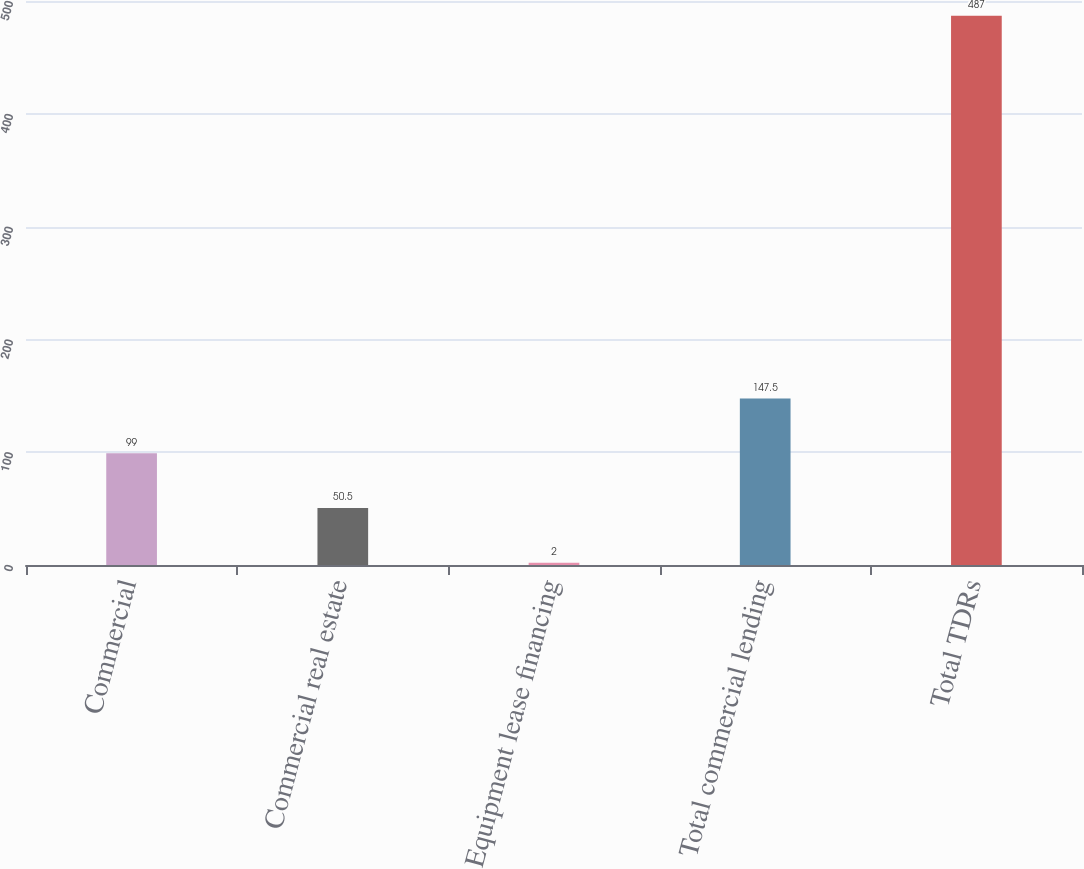<chart> <loc_0><loc_0><loc_500><loc_500><bar_chart><fcel>Commercial<fcel>Commercial real estate<fcel>Equipment lease financing<fcel>Total commercial lending<fcel>Total TDRs<nl><fcel>99<fcel>50.5<fcel>2<fcel>147.5<fcel>487<nl></chart> 